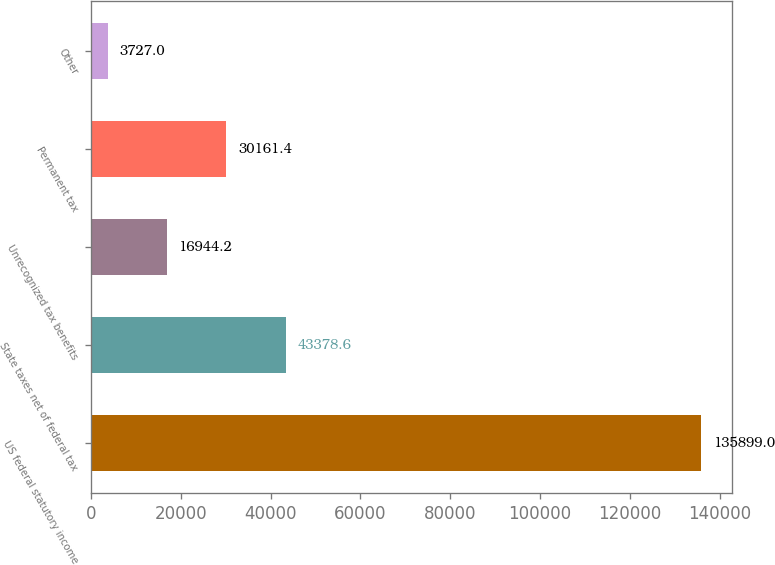Convert chart to OTSL. <chart><loc_0><loc_0><loc_500><loc_500><bar_chart><fcel>US federal statutory income<fcel>State taxes net of federal tax<fcel>Unrecognized tax benefits<fcel>Permanent tax<fcel>Other<nl><fcel>135899<fcel>43378.6<fcel>16944.2<fcel>30161.4<fcel>3727<nl></chart> 